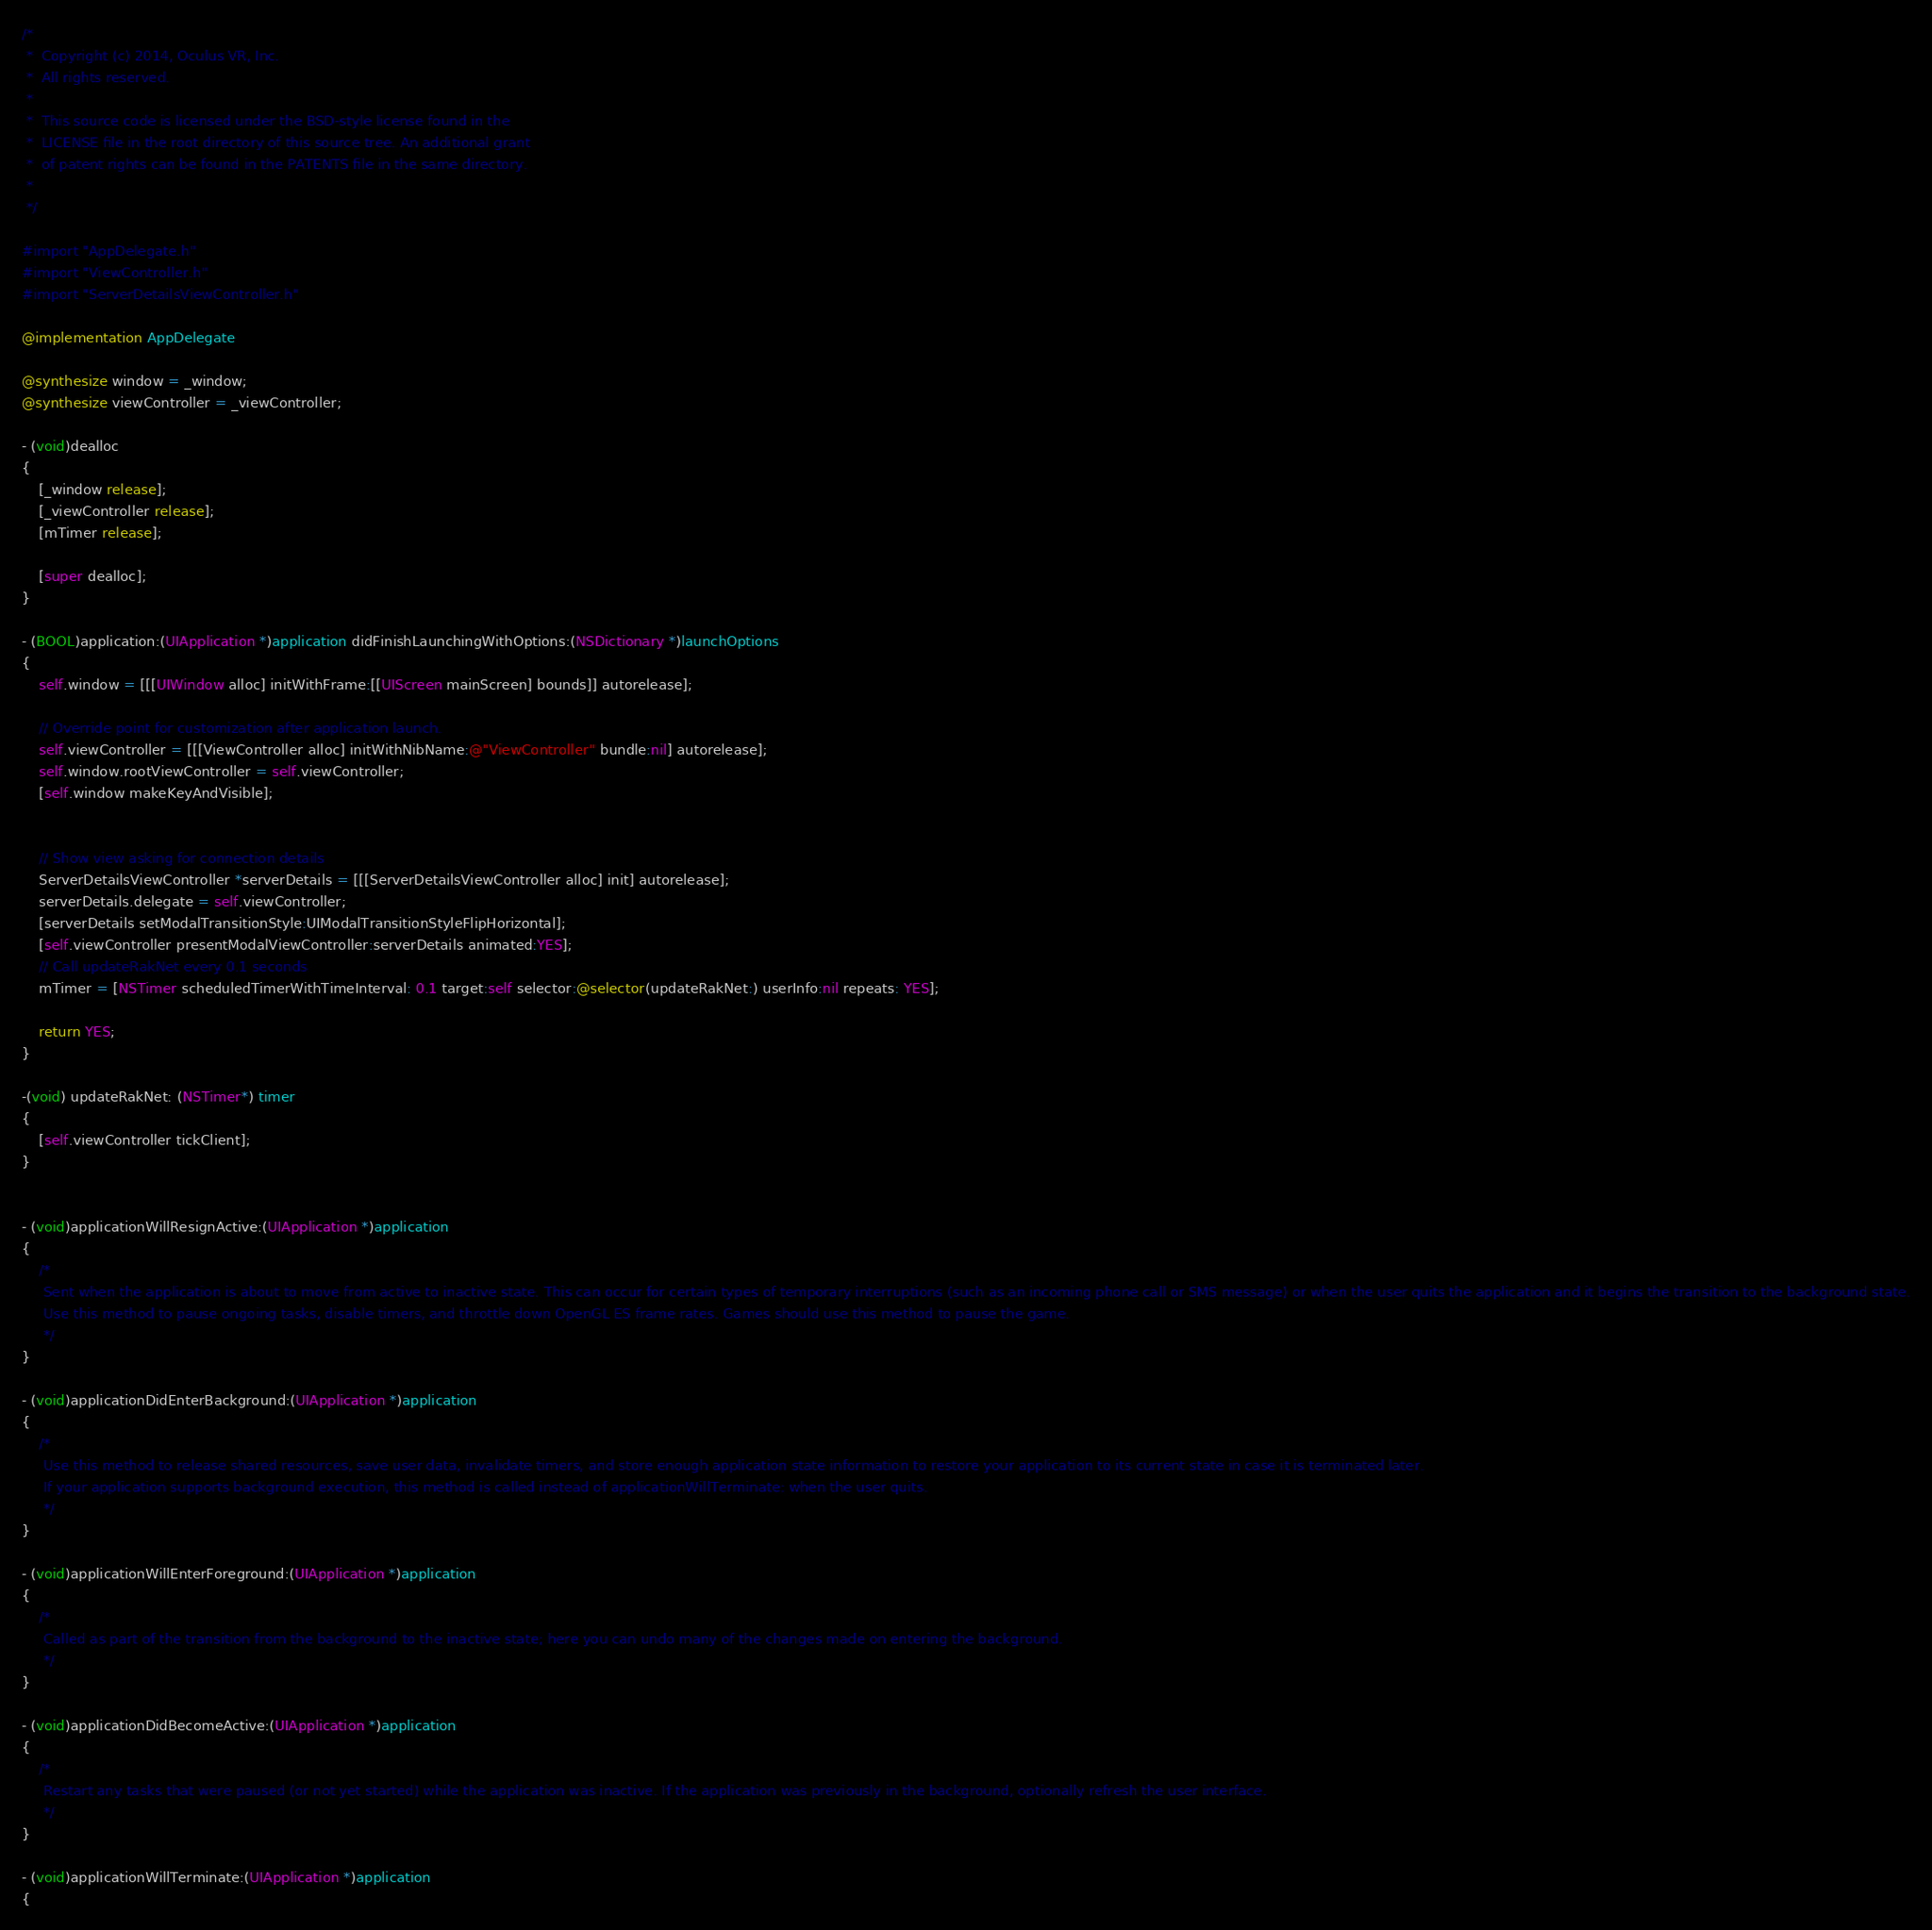Convert code to text. <code><loc_0><loc_0><loc_500><loc_500><_ObjectiveC_>/*
 *  Copyright (c) 2014, Oculus VR, Inc.
 *  All rights reserved.
 *
 *  This source code is licensed under the BSD-style license found in the
 *  LICENSE file in the root directory of this source tree. An additional grant 
 *  of patent rights can be found in the PATENTS file in the same directory.
 *
 */

#import "AppDelegate.h"
#import "ViewController.h"
#import "ServerDetailsViewController.h"

@implementation AppDelegate

@synthesize window = _window;
@synthesize viewController = _viewController;

- (void)dealloc
{
    [_window release];
    [_viewController release];
    [mTimer release];
    
    [super dealloc];
}

- (BOOL)application:(UIApplication *)application didFinishLaunchingWithOptions:(NSDictionary *)launchOptions
{
    self.window = [[[UIWindow alloc] initWithFrame:[[UIScreen mainScreen] bounds]] autorelease];

    // Override point for customization after application launch.
    self.viewController = [[[ViewController alloc] initWithNibName:@"ViewController" bundle:nil] autorelease];
    self.window.rootViewController = self.viewController;
    [self.window makeKeyAndVisible];
    
    
    // Show view asking for connection details
	ServerDetailsViewController *serverDetails = [[[ServerDetailsViewController alloc] init] autorelease];
    serverDetails.delegate = self.viewController;
    [serverDetails setModalTransitionStyle:UIModalTransitionStyleFlipHorizontal];
    [self.viewController presentModalViewController:serverDetails animated:YES];
    // Call updateRakNet every 0.1 seconds
    mTimer = [NSTimer scheduledTimerWithTimeInterval: 0.1 target:self selector:@selector(updateRakNet:) userInfo:nil repeats: YES];
    
    return YES;
}

-(void) updateRakNet: (NSTimer*) timer
{
    [self.viewController tickClient];
}


- (void)applicationWillResignActive:(UIApplication *)application
{
    /*
     Sent when the application is about to move from active to inactive state. This can occur for certain types of temporary interruptions (such as an incoming phone call or SMS message) or when the user quits the application and it begins the transition to the background state.
     Use this method to pause ongoing tasks, disable timers, and throttle down OpenGL ES frame rates. Games should use this method to pause the game.
     */
}

- (void)applicationDidEnterBackground:(UIApplication *)application
{
    /*
     Use this method to release shared resources, save user data, invalidate timers, and store enough application state information to restore your application to its current state in case it is terminated later. 
     If your application supports background execution, this method is called instead of applicationWillTerminate: when the user quits.
     */
}

- (void)applicationWillEnterForeground:(UIApplication *)application
{
    /*
     Called as part of the transition from the background to the inactive state; here you can undo many of the changes made on entering the background.
     */
}

- (void)applicationDidBecomeActive:(UIApplication *)application
{
    /*
     Restart any tasks that were paused (or not yet started) while the application was inactive. If the application was previously in the background, optionally refresh the user interface.
     */
}

- (void)applicationWillTerminate:(UIApplication *)application
{</code> 